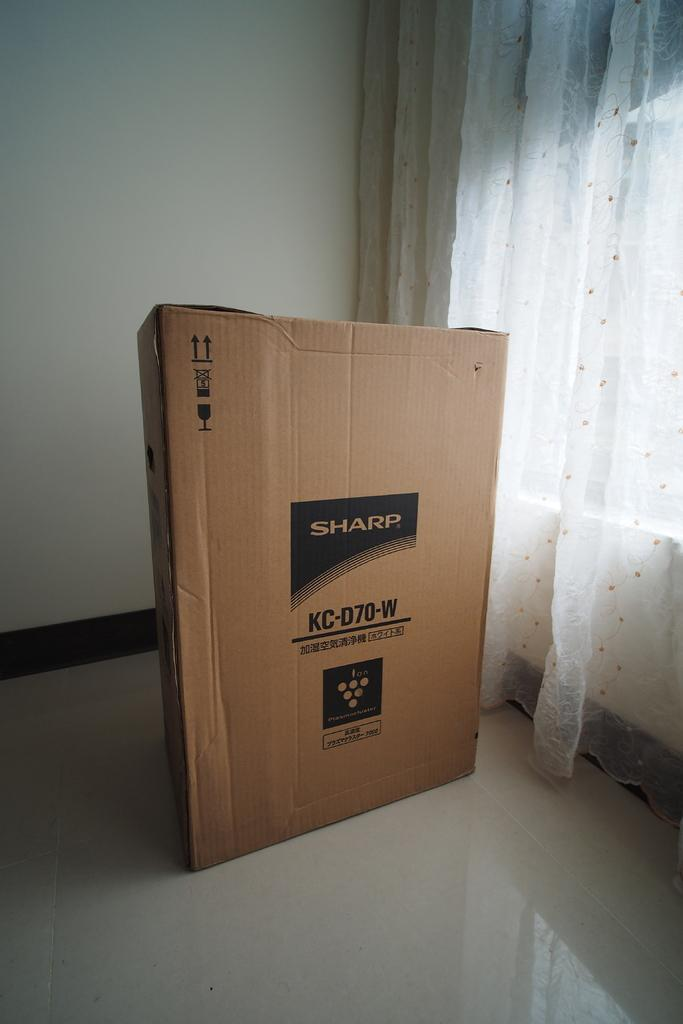<image>
Relay a brief, clear account of the picture shown. A large cardboard box for a Sharp device sitting on a white linoleum floor next to a window. 